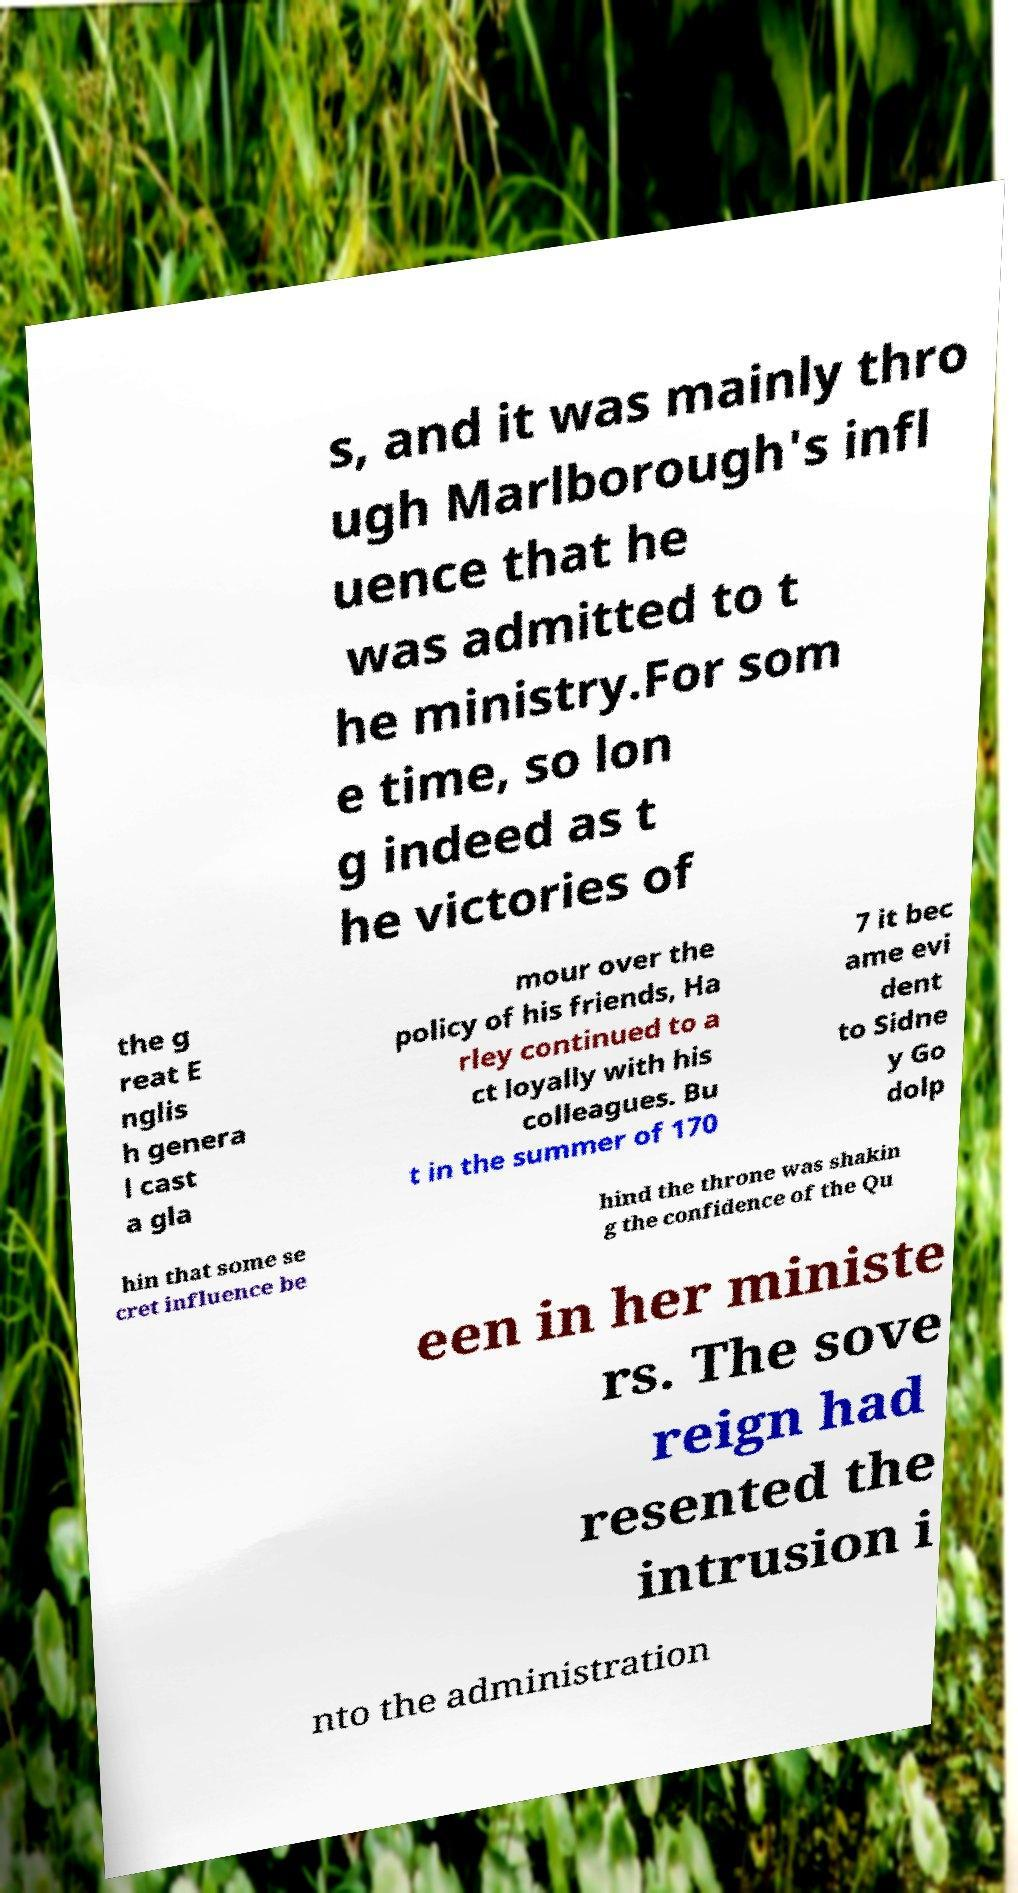Could you extract and type out the text from this image? s, and it was mainly thro ugh Marlborough's infl uence that he was admitted to t he ministry.For som e time, so lon g indeed as t he victories of the g reat E nglis h genera l cast a gla mour over the policy of his friends, Ha rley continued to a ct loyally with his colleagues. Bu t in the summer of 170 7 it bec ame evi dent to Sidne y Go dolp hin that some se cret influence be hind the throne was shakin g the confidence of the Qu een in her ministe rs. The sove reign had resented the intrusion i nto the administration 